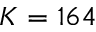<formula> <loc_0><loc_0><loc_500><loc_500>K = 1 6 4</formula> 